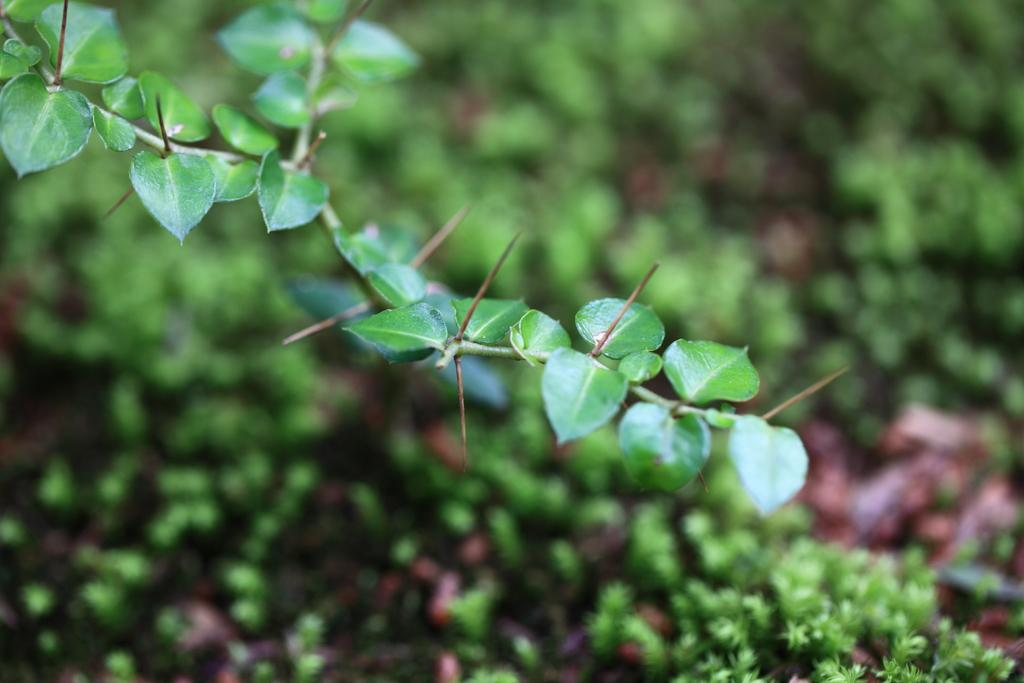What type of vegetation can be seen in the image? There are leaves in the image. What color are the leaves in the image? The leaves are green in color. What can be seen in the background of the image? There are plants in the background of the image. What color are the plants in the background? The plants in the background are green in color. How many men are visible on the journey in the image? There are no men or journeys depicted in the image; it features leaves and plants. 